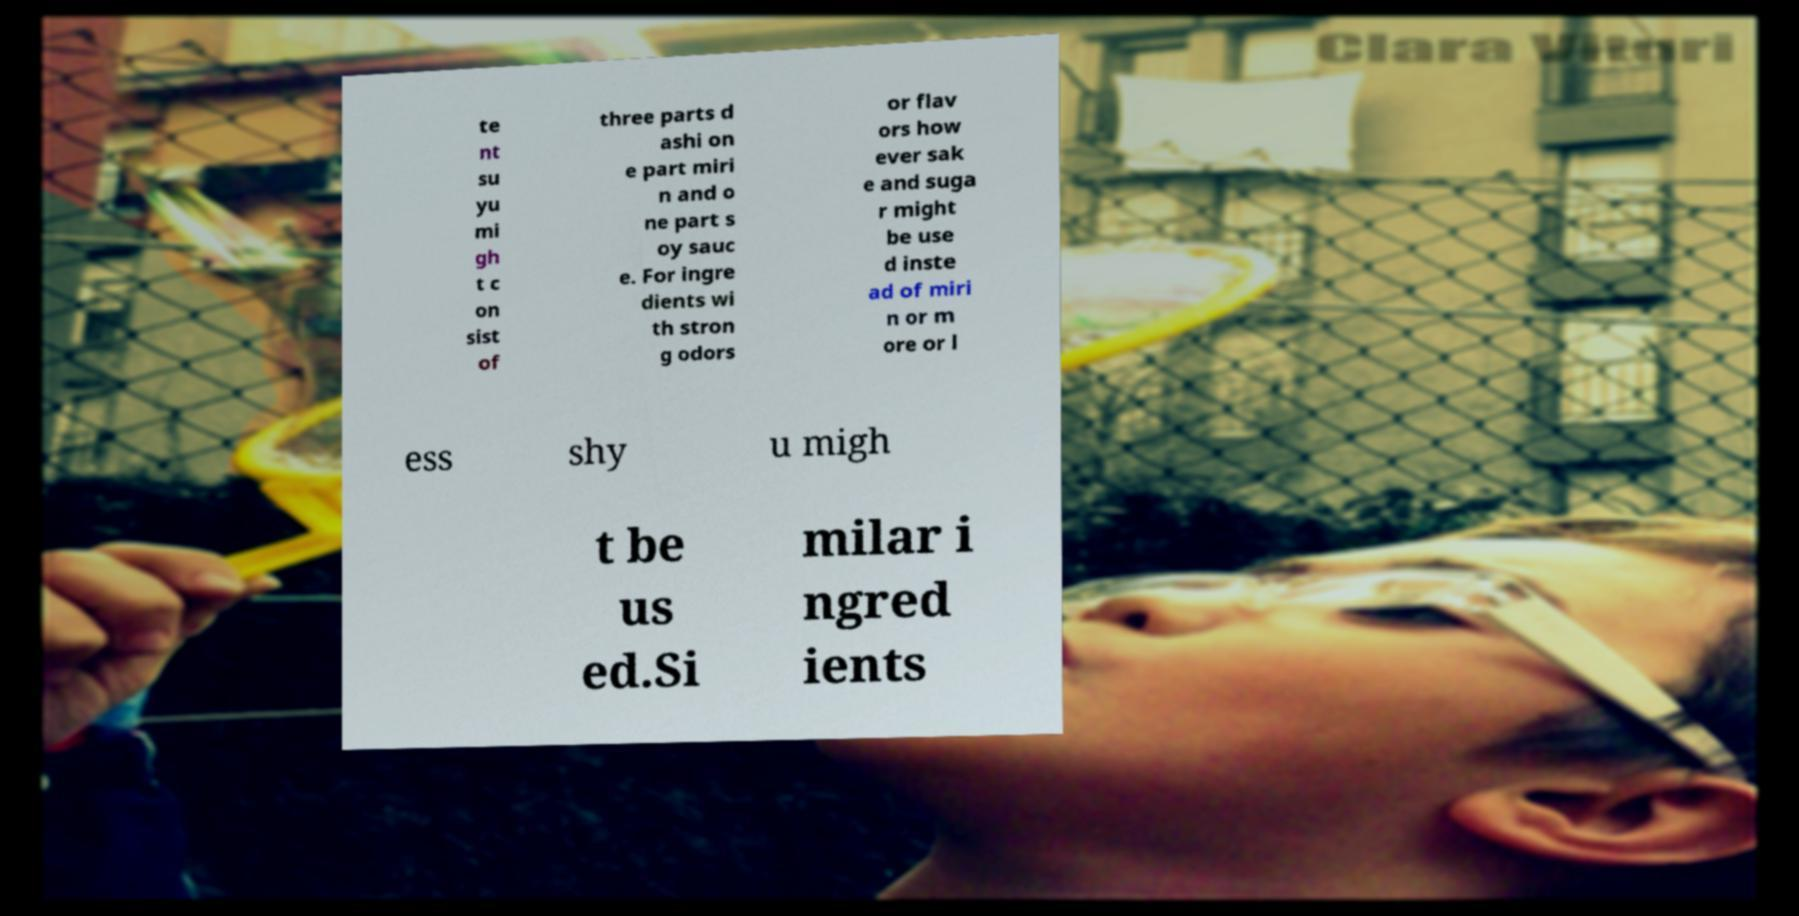Please read and relay the text visible in this image. What does it say? te nt su yu mi gh t c on sist of three parts d ashi on e part miri n and o ne part s oy sauc e. For ingre dients wi th stron g odors or flav ors how ever sak e and suga r might be use d inste ad of miri n or m ore or l ess shy u migh t be us ed.Si milar i ngred ients 